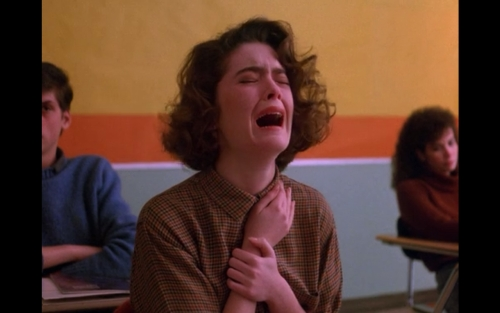What can you infer about the setting of this image? The setting appears to be an indoor environment, likely a classroom given the presence of other individuals seated in the background, who seem to be students. The colorful walls and the casual attire of the people suggest a relaxed, educational atmosphere. 